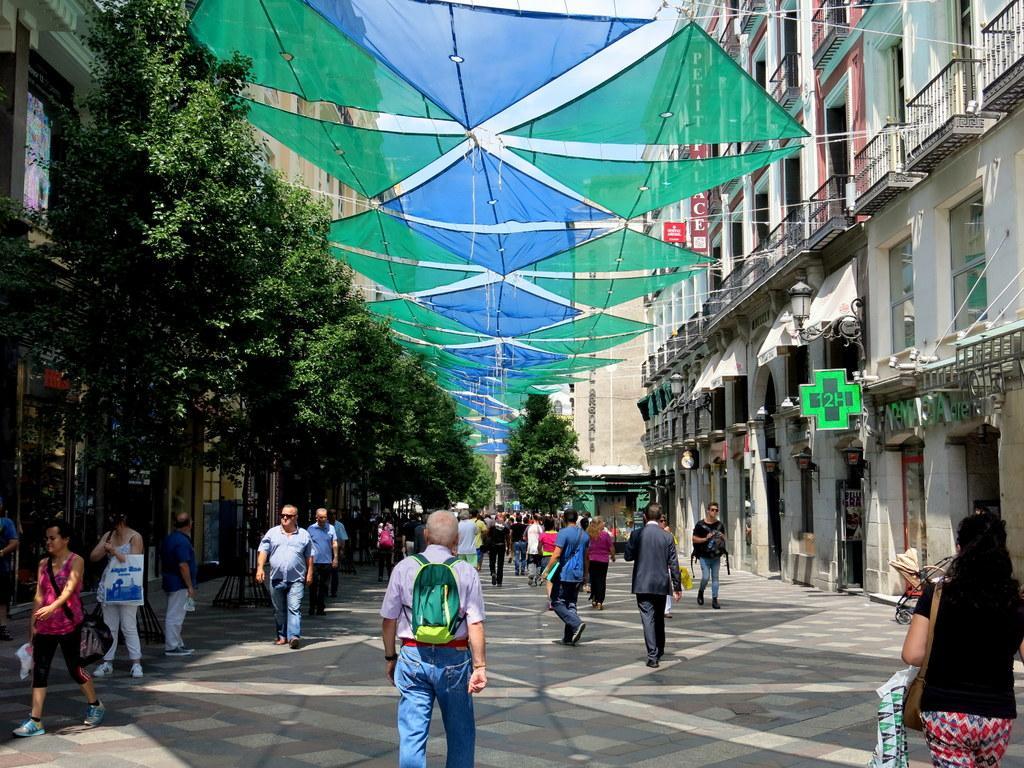Can you describe this image briefly? In this picture there are people in the center of the image and there are climbers on the left side of the image and there are shops in the image, it seems to be the road side view. 